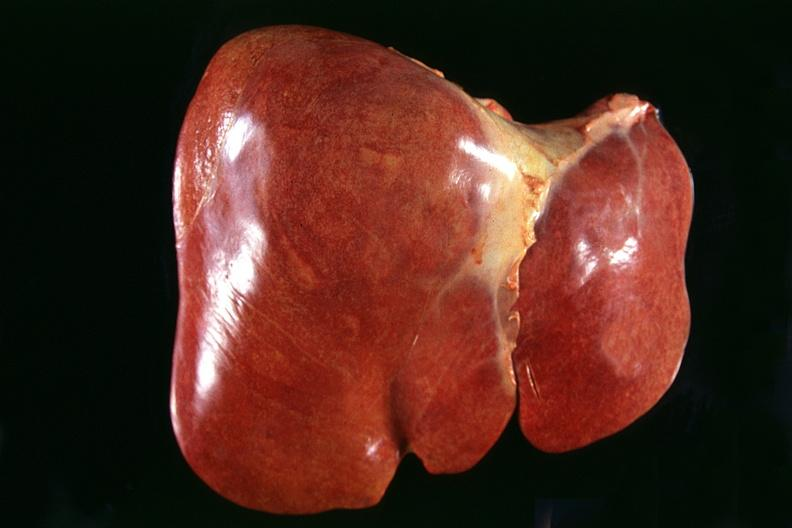does this image show normal liver?
Answer the question using a single word or phrase. Yes 